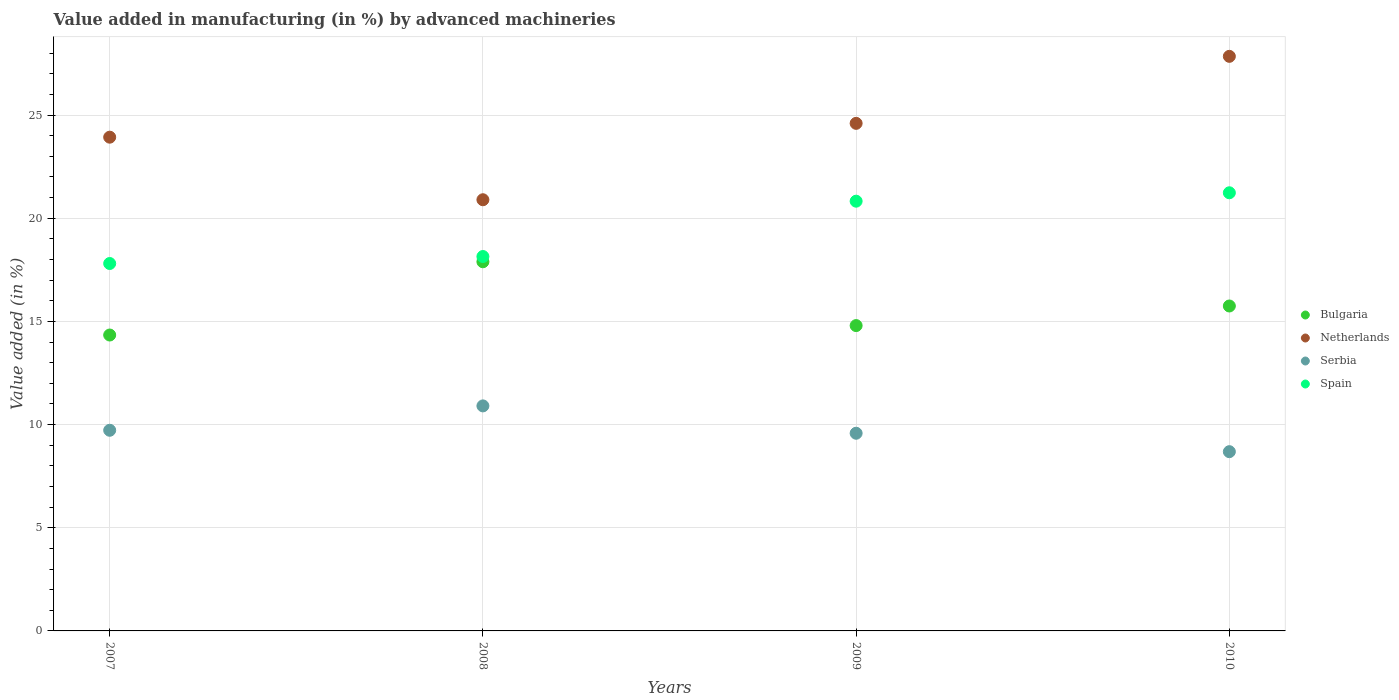How many different coloured dotlines are there?
Provide a short and direct response. 4. Is the number of dotlines equal to the number of legend labels?
Your answer should be very brief. Yes. What is the percentage of value added in manufacturing by advanced machineries in Bulgaria in 2009?
Provide a succinct answer. 14.8. Across all years, what is the maximum percentage of value added in manufacturing by advanced machineries in Serbia?
Make the answer very short. 10.91. Across all years, what is the minimum percentage of value added in manufacturing by advanced machineries in Serbia?
Give a very brief answer. 8.69. In which year was the percentage of value added in manufacturing by advanced machineries in Netherlands maximum?
Your answer should be compact. 2010. What is the total percentage of value added in manufacturing by advanced machineries in Serbia in the graph?
Your answer should be very brief. 38.9. What is the difference between the percentage of value added in manufacturing by advanced machineries in Serbia in 2008 and that in 2009?
Offer a terse response. 1.33. What is the difference between the percentage of value added in manufacturing by advanced machineries in Bulgaria in 2007 and the percentage of value added in manufacturing by advanced machineries in Serbia in 2010?
Offer a terse response. 5.65. What is the average percentage of value added in manufacturing by advanced machineries in Spain per year?
Keep it short and to the point. 19.5. In the year 2008, what is the difference between the percentage of value added in manufacturing by advanced machineries in Netherlands and percentage of value added in manufacturing by advanced machineries in Bulgaria?
Make the answer very short. 3.01. What is the ratio of the percentage of value added in manufacturing by advanced machineries in Serbia in 2007 to that in 2010?
Your answer should be very brief. 1.12. What is the difference between the highest and the second highest percentage of value added in manufacturing by advanced machineries in Bulgaria?
Make the answer very short. 2.14. What is the difference between the highest and the lowest percentage of value added in manufacturing by advanced machineries in Netherlands?
Make the answer very short. 6.95. Is it the case that in every year, the sum of the percentage of value added in manufacturing by advanced machineries in Bulgaria and percentage of value added in manufacturing by advanced machineries in Serbia  is greater than the sum of percentage of value added in manufacturing by advanced machineries in Spain and percentage of value added in manufacturing by advanced machineries in Netherlands?
Your response must be concise. No. Is it the case that in every year, the sum of the percentage of value added in manufacturing by advanced machineries in Serbia and percentage of value added in manufacturing by advanced machineries in Bulgaria  is greater than the percentage of value added in manufacturing by advanced machineries in Spain?
Provide a succinct answer. Yes. Does the percentage of value added in manufacturing by advanced machineries in Bulgaria monotonically increase over the years?
Provide a short and direct response. No. Is the percentage of value added in manufacturing by advanced machineries in Serbia strictly greater than the percentage of value added in manufacturing by advanced machineries in Bulgaria over the years?
Give a very brief answer. No. Where does the legend appear in the graph?
Ensure brevity in your answer.  Center right. What is the title of the graph?
Make the answer very short. Value added in manufacturing (in %) by advanced machineries. Does "Tonga" appear as one of the legend labels in the graph?
Offer a terse response. No. What is the label or title of the Y-axis?
Offer a terse response. Value added (in %). What is the Value added (in %) in Bulgaria in 2007?
Your answer should be very brief. 14.34. What is the Value added (in %) in Netherlands in 2007?
Your answer should be compact. 23.93. What is the Value added (in %) in Serbia in 2007?
Keep it short and to the point. 9.72. What is the Value added (in %) in Spain in 2007?
Provide a short and direct response. 17.81. What is the Value added (in %) of Bulgaria in 2008?
Your answer should be compact. 17.89. What is the Value added (in %) of Netherlands in 2008?
Make the answer very short. 20.9. What is the Value added (in %) of Serbia in 2008?
Give a very brief answer. 10.91. What is the Value added (in %) in Spain in 2008?
Give a very brief answer. 18.14. What is the Value added (in %) in Bulgaria in 2009?
Provide a short and direct response. 14.8. What is the Value added (in %) in Netherlands in 2009?
Give a very brief answer. 24.6. What is the Value added (in %) of Serbia in 2009?
Offer a very short reply. 9.58. What is the Value added (in %) in Spain in 2009?
Keep it short and to the point. 20.83. What is the Value added (in %) in Bulgaria in 2010?
Your answer should be very brief. 15.75. What is the Value added (in %) of Netherlands in 2010?
Make the answer very short. 27.85. What is the Value added (in %) in Serbia in 2010?
Give a very brief answer. 8.69. What is the Value added (in %) of Spain in 2010?
Your answer should be compact. 21.23. Across all years, what is the maximum Value added (in %) in Bulgaria?
Give a very brief answer. 17.89. Across all years, what is the maximum Value added (in %) of Netherlands?
Provide a short and direct response. 27.85. Across all years, what is the maximum Value added (in %) in Serbia?
Ensure brevity in your answer.  10.91. Across all years, what is the maximum Value added (in %) in Spain?
Provide a succinct answer. 21.23. Across all years, what is the minimum Value added (in %) of Bulgaria?
Your answer should be very brief. 14.34. Across all years, what is the minimum Value added (in %) in Netherlands?
Provide a succinct answer. 20.9. Across all years, what is the minimum Value added (in %) in Serbia?
Offer a terse response. 8.69. Across all years, what is the minimum Value added (in %) of Spain?
Your answer should be compact. 17.81. What is the total Value added (in %) of Bulgaria in the graph?
Your answer should be compact. 62.78. What is the total Value added (in %) of Netherlands in the graph?
Give a very brief answer. 97.27. What is the total Value added (in %) of Serbia in the graph?
Your answer should be compact. 38.9. What is the total Value added (in %) of Spain in the graph?
Offer a very short reply. 78.01. What is the difference between the Value added (in %) in Bulgaria in 2007 and that in 2008?
Offer a terse response. -3.55. What is the difference between the Value added (in %) of Netherlands in 2007 and that in 2008?
Your response must be concise. 3.03. What is the difference between the Value added (in %) in Serbia in 2007 and that in 2008?
Your response must be concise. -1.18. What is the difference between the Value added (in %) of Spain in 2007 and that in 2008?
Your answer should be very brief. -0.34. What is the difference between the Value added (in %) in Bulgaria in 2007 and that in 2009?
Offer a very short reply. -0.46. What is the difference between the Value added (in %) in Netherlands in 2007 and that in 2009?
Offer a very short reply. -0.67. What is the difference between the Value added (in %) in Serbia in 2007 and that in 2009?
Offer a terse response. 0.14. What is the difference between the Value added (in %) of Spain in 2007 and that in 2009?
Provide a short and direct response. -3.02. What is the difference between the Value added (in %) in Bulgaria in 2007 and that in 2010?
Make the answer very short. -1.41. What is the difference between the Value added (in %) of Netherlands in 2007 and that in 2010?
Offer a very short reply. -3.92. What is the difference between the Value added (in %) of Spain in 2007 and that in 2010?
Provide a succinct answer. -3.43. What is the difference between the Value added (in %) of Bulgaria in 2008 and that in 2009?
Provide a short and direct response. 3.09. What is the difference between the Value added (in %) in Netherlands in 2008 and that in 2009?
Offer a terse response. -3.7. What is the difference between the Value added (in %) in Serbia in 2008 and that in 2009?
Ensure brevity in your answer.  1.33. What is the difference between the Value added (in %) in Spain in 2008 and that in 2009?
Offer a very short reply. -2.68. What is the difference between the Value added (in %) in Bulgaria in 2008 and that in 2010?
Your answer should be very brief. 2.14. What is the difference between the Value added (in %) in Netherlands in 2008 and that in 2010?
Keep it short and to the point. -6.95. What is the difference between the Value added (in %) in Serbia in 2008 and that in 2010?
Your answer should be compact. 2.22. What is the difference between the Value added (in %) of Spain in 2008 and that in 2010?
Give a very brief answer. -3.09. What is the difference between the Value added (in %) in Bulgaria in 2009 and that in 2010?
Make the answer very short. -0.95. What is the difference between the Value added (in %) of Netherlands in 2009 and that in 2010?
Make the answer very short. -3.25. What is the difference between the Value added (in %) in Serbia in 2009 and that in 2010?
Keep it short and to the point. 0.89. What is the difference between the Value added (in %) in Spain in 2009 and that in 2010?
Your response must be concise. -0.41. What is the difference between the Value added (in %) in Bulgaria in 2007 and the Value added (in %) in Netherlands in 2008?
Your response must be concise. -6.56. What is the difference between the Value added (in %) of Bulgaria in 2007 and the Value added (in %) of Serbia in 2008?
Keep it short and to the point. 3.43. What is the difference between the Value added (in %) of Bulgaria in 2007 and the Value added (in %) of Spain in 2008?
Ensure brevity in your answer.  -3.8. What is the difference between the Value added (in %) of Netherlands in 2007 and the Value added (in %) of Serbia in 2008?
Offer a very short reply. 13.02. What is the difference between the Value added (in %) of Netherlands in 2007 and the Value added (in %) of Spain in 2008?
Your answer should be compact. 5.78. What is the difference between the Value added (in %) in Serbia in 2007 and the Value added (in %) in Spain in 2008?
Make the answer very short. -8.42. What is the difference between the Value added (in %) in Bulgaria in 2007 and the Value added (in %) in Netherlands in 2009?
Offer a terse response. -10.26. What is the difference between the Value added (in %) in Bulgaria in 2007 and the Value added (in %) in Serbia in 2009?
Keep it short and to the point. 4.76. What is the difference between the Value added (in %) of Bulgaria in 2007 and the Value added (in %) of Spain in 2009?
Your answer should be compact. -6.49. What is the difference between the Value added (in %) in Netherlands in 2007 and the Value added (in %) in Serbia in 2009?
Provide a short and direct response. 14.35. What is the difference between the Value added (in %) in Netherlands in 2007 and the Value added (in %) in Spain in 2009?
Your response must be concise. 3.1. What is the difference between the Value added (in %) of Serbia in 2007 and the Value added (in %) of Spain in 2009?
Offer a very short reply. -11.1. What is the difference between the Value added (in %) in Bulgaria in 2007 and the Value added (in %) in Netherlands in 2010?
Ensure brevity in your answer.  -13.51. What is the difference between the Value added (in %) of Bulgaria in 2007 and the Value added (in %) of Serbia in 2010?
Offer a terse response. 5.65. What is the difference between the Value added (in %) of Bulgaria in 2007 and the Value added (in %) of Spain in 2010?
Your response must be concise. -6.89. What is the difference between the Value added (in %) of Netherlands in 2007 and the Value added (in %) of Serbia in 2010?
Your answer should be compact. 15.24. What is the difference between the Value added (in %) of Netherlands in 2007 and the Value added (in %) of Spain in 2010?
Your answer should be very brief. 2.69. What is the difference between the Value added (in %) of Serbia in 2007 and the Value added (in %) of Spain in 2010?
Give a very brief answer. -11.51. What is the difference between the Value added (in %) in Bulgaria in 2008 and the Value added (in %) in Netherlands in 2009?
Offer a very short reply. -6.71. What is the difference between the Value added (in %) of Bulgaria in 2008 and the Value added (in %) of Serbia in 2009?
Ensure brevity in your answer.  8.31. What is the difference between the Value added (in %) in Bulgaria in 2008 and the Value added (in %) in Spain in 2009?
Make the answer very short. -2.94. What is the difference between the Value added (in %) in Netherlands in 2008 and the Value added (in %) in Serbia in 2009?
Provide a short and direct response. 11.32. What is the difference between the Value added (in %) in Netherlands in 2008 and the Value added (in %) in Spain in 2009?
Give a very brief answer. 0.07. What is the difference between the Value added (in %) in Serbia in 2008 and the Value added (in %) in Spain in 2009?
Your answer should be very brief. -9.92. What is the difference between the Value added (in %) in Bulgaria in 2008 and the Value added (in %) in Netherlands in 2010?
Your answer should be compact. -9.95. What is the difference between the Value added (in %) of Bulgaria in 2008 and the Value added (in %) of Serbia in 2010?
Ensure brevity in your answer.  9.2. What is the difference between the Value added (in %) in Bulgaria in 2008 and the Value added (in %) in Spain in 2010?
Provide a succinct answer. -3.34. What is the difference between the Value added (in %) in Netherlands in 2008 and the Value added (in %) in Serbia in 2010?
Make the answer very short. 12.21. What is the difference between the Value added (in %) of Netherlands in 2008 and the Value added (in %) of Spain in 2010?
Provide a short and direct response. -0.34. What is the difference between the Value added (in %) in Serbia in 2008 and the Value added (in %) in Spain in 2010?
Provide a short and direct response. -10.33. What is the difference between the Value added (in %) of Bulgaria in 2009 and the Value added (in %) of Netherlands in 2010?
Offer a terse response. -13.05. What is the difference between the Value added (in %) of Bulgaria in 2009 and the Value added (in %) of Serbia in 2010?
Provide a succinct answer. 6.11. What is the difference between the Value added (in %) in Bulgaria in 2009 and the Value added (in %) in Spain in 2010?
Provide a short and direct response. -6.44. What is the difference between the Value added (in %) in Netherlands in 2009 and the Value added (in %) in Serbia in 2010?
Keep it short and to the point. 15.91. What is the difference between the Value added (in %) in Netherlands in 2009 and the Value added (in %) in Spain in 2010?
Give a very brief answer. 3.36. What is the difference between the Value added (in %) in Serbia in 2009 and the Value added (in %) in Spain in 2010?
Provide a short and direct response. -11.65. What is the average Value added (in %) in Bulgaria per year?
Your answer should be compact. 15.69. What is the average Value added (in %) of Netherlands per year?
Your response must be concise. 24.32. What is the average Value added (in %) of Serbia per year?
Keep it short and to the point. 9.72. What is the average Value added (in %) in Spain per year?
Offer a very short reply. 19.5. In the year 2007, what is the difference between the Value added (in %) in Bulgaria and Value added (in %) in Netherlands?
Offer a terse response. -9.59. In the year 2007, what is the difference between the Value added (in %) in Bulgaria and Value added (in %) in Serbia?
Ensure brevity in your answer.  4.62. In the year 2007, what is the difference between the Value added (in %) in Bulgaria and Value added (in %) in Spain?
Make the answer very short. -3.47. In the year 2007, what is the difference between the Value added (in %) in Netherlands and Value added (in %) in Serbia?
Provide a short and direct response. 14.2. In the year 2007, what is the difference between the Value added (in %) of Netherlands and Value added (in %) of Spain?
Provide a short and direct response. 6.12. In the year 2007, what is the difference between the Value added (in %) in Serbia and Value added (in %) in Spain?
Your answer should be very brief. -8.08. In the year 2008, what is the difference between the Value added (in %) of Bulgaria and Value added (in %) of Netherlands?
Your answer should be compact. -3.01. In the year 2008, what is the difference between the Value added (in %) in Bulgaria and Value added (in %) in Serbia?
Offer a terse response. 6.99. In the year 2008, what is the difference between the Value added (in %) in Bulgaria and Value added (in %) in Spain?
Your answer should be compact. -0.25. In the year 2008, what is the difference between the Value added (in %) of Netherlands and Value added (in %) of Serbia?
Offer a very short reply. 9.99. In the year 2008, what is the difference between the Value added (in %) of Netherlands and Value added (in %) of Spain?
Make the answer very short. 2.75. In the year 2008, what is the difference between the Value added (in %) in Serbia and Value added (in %) in Spain?
Your response must be concise. -7.24. In the year 2009, what is the difference between the Value added (in %) in Bulgaria and Value added (in %) in Netherlands?
Your response must be concise. -9.8. In the year 2009, what is the difference between the Value added (in %) of Bulgaria and Value added (in %) of Serbia?
Provide a succinct answer. 5.22. In the year 2009, what is the difference between the Value added (in %) of Bulgaria and Value added (in %) of Spain?
Provide a short and direct response. -6.03. In the year 2009, what is the difference between the Value added (in %) in Netherlands and Value added (in %) in Serbia?
Ensure brevity in your answer.  15.02. In the year 2009, what is the difference between the Value added (in %) in Netherlands and Value added (in %) in Spain?
Ensure brevity in your answer.  3.77. In the year 2009, what is the difference between the Value added (in %) of Serbia and Value added (in %) of Spain?
Give a very brief answer. -11.25. In the year 2010, what is the difference between the Value added (in %) of Bulgaria and Value added (in %) of Netherlands?
Offer a very short reply. -12.1. In the year 2010, what is the difference between the Value added (in %) of Bulgaria and Value added (in %) of Serbia?
Ensure brevity in your answer.  7.06. In the year 2010, what is the difference between the Value added (in %) of Bulgaria and Value added (in %) of Spain?
Ensure brevity in your answer.  -5.49. In the year 2010, what is the difference between the Value added (in %) of Netherlands and Value added (in %) of Serbia?
Keep it short and to the point. 19.16. In the year 2010, what is the difference between the Value added (in %) of Netherlands and Value added (in %) of Spain?
Make the answer very short. 6.61. In the year 2010, what is the difference between the Value added (in %) in Serbia and Value added (in %) in Spain?
Give a very brief answer. -12.55. What is the ratio of the Value added (in %) of Bulgaria in 2007 to that in 2008?
Offer a terse response. 0.8. What is the ratio of the Value added (in %) of Netherlands in 2007 to that in 2008?
Offer a very short reply. 1.15. What is the ratio of the Value added (in %) of Serbia in 2007 to that in 2008?
Offer a very short reply. 0.89. What is the ratio of the Value added (in %) of Spain in 2007 to that in 2008?
Ensure brevity in your answer.  0.98. What is the ratio of the Value added (in %) of Bulgaria in 2007 to that in 2009?
Your answer should be very brief. 0.97. What is the ratio of the Value added (in %) of Netherlands in 2007 to that in 2009?
Provide a succinct answer. 0.97. What is the ratio of the Value added (in %) of Spain in 2007 to that in 2009?
Offer a terse response. 0.85. What is the ratio of the Value added (in %) of Bulgaria in 2007 to that in 2010?
Your answer should be very brief. 0.91. What is the ratio of the Value added (in %) of Netherlands in 2007 to that in 2010?
Your response must be concise. 0.86. What is the ratio of the Value added (in %) of Serbia in 2007 to that in 2010?
Keep it short and to the point. 1.12. What is the ratio of the Value added (in %) of Spain in 2007 to that in 2010?
Your answer should be very brief. 0.84. What is the ratio of the Value added (in %) in Bulgaria in 2008 to that in 2009?
Provide a short and direct response. 1.21. What is the ratio of the Value added (in %) of Netherlands in 2008 to that in 2009?
Your answer should be compact. 0.85. What is the ratio of the Value added (in %) of Serbia in 2008 to that in 2009?
Your answer should be compact. 1.14. What is the ratio of the Value added (in %) in Spain in 2008 to that in 2009?
Give a very brief answer. 0.87. What is the ratio of the Value added (in %) in Bulgaria in 2008 to that in 2010?
Keep it short and to the point. 1.14. What is the ratio of the Value added (in %) in Netherlands in 2008 to that in 2010?
Provide a short and direct response. 0.75. What is the ratio of the Value added (in %) of Serbia in 2008 to that in 2010?
Make the answer very short. 1.26. What is the ratio of the Value added (in %) of Spain in 2008 to that in 2010?
Keep it short and to the point. 0.85. What is the ratio of the Value added (in %) of Bulgaria in 2009 to that in 2010?
Give a very brief answer. 0.94. What is the ratio of the Value added (in %) in Netherlands in 2009 to that in 2010?
Keep it short and to the point. 0.88. What is the ratio of the Value added (in %) in Serbia in 2009 to that in 2010?
Your response must be concise. 1.1. What is the ratio of the Value added (in %) in Spain in 2009 to that in 2010?
Ensure brevity in your answer.  0.98. What is the difference between the highest and the second highest Value added (in %) in Bulgaria?
Offer a very short reply. 2.14. What is the difference between the highest and the second highest Value added (in %) of Netherlands?
Give a very brief answer. 3.25. What is the difference between the highest and the second highest Value added (in %) in Serbia?
Provide a short and direct response. 1.18. What is the difference between the highest and the second highest Value added (in %) in Spain?
Your answer should be compact. 0.41. What is the difference between the highest and the lowest Value added (in %) in Bulgaria?
Ensure brevity in your answer.  3.55. What is the difference between the highest and the lowest Value added (in %) in Netherlands?
Your response must be concise. 6.95. What is the difference between the highest and the lowest Value added (in %) of Serbia?
Your answer should be compact. 2.22. What is the difference between the highest and the lowest Value added (in %) in Spain?
Your answer should be very brief. 3.43. 